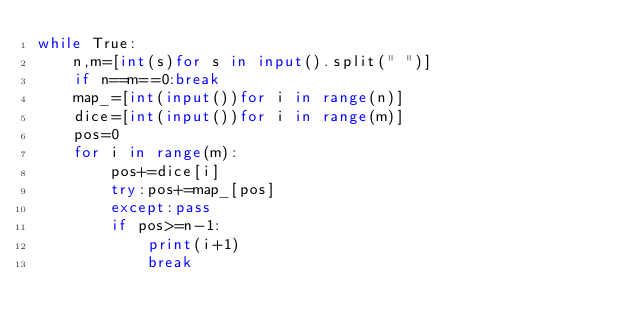<code> <loc_0><loc_0><loc_500><loc_500><_Python_>while True:
    n,m=[int(s)for s in input().split(" ")]
    if n==m==0:break
    map_=[int(input())for i in range(n)]
    dice=[int(input())for i in range(m)]
    pos=0
    for i in range(m):
        pos+=dice[i]
        try:pos+=map_[pos]
        except:pass
        if pos>=n-1:
            print(i+1)
            break</code> 